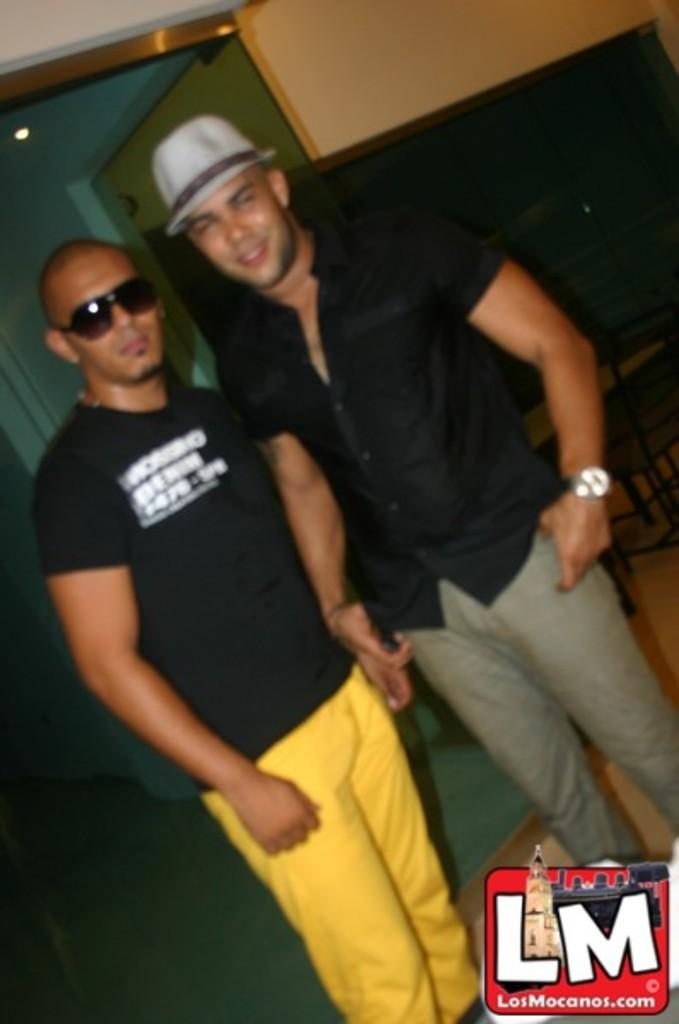How many people are in the image? There are two persons standing in the image. What color is the object in the image? There is a black color object in the image. What type of furniture is present in the image? There is a bench in the image. What can be seen on the ceiling in the background of the image? There is a light on the ceiling in the background of the image. Are there any pets visible in the image? There are no pets visible in the image. What type of farm animals can be seen in the image? There are no farm animals present in the image. 